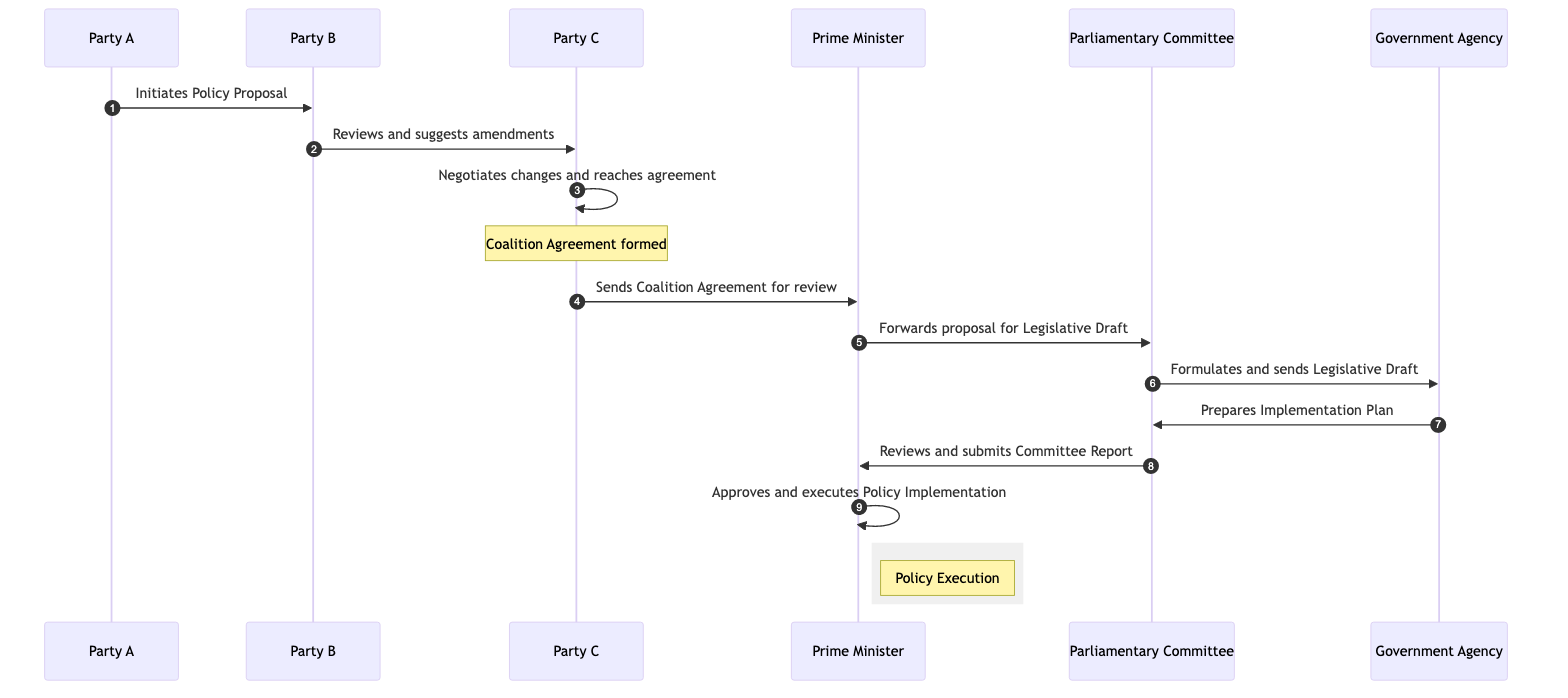What is the first action in the sequence? The first action is initiated by Party A, where they propose a Policy Proposal to Party B. This is the starting point of the diagram, signifying the initiation of the policy development process.
Answer: Party A initiates a Policy Proposal How many parties are involved in the diagram? The diagram includes three parties: Party A, Party B, and Party C. They are all mentioned as actors in the sequence, contributing to the policy development process.
Answer: Three Who reviews the Coalition Agreement after Party C? After Party C sends the Coalition Agreement, it is reviewed by the Prime Minister. This action is represented clearly in the diagram as the Prime Minister’s involvement in the agreement process.
Answer: Prime Minister Which participant sends the Legislative Draft to the Government Agency? The Parliamentary Committee sends the Legislative Draft to the Government Agency. This action indicates the flow of the Legislative Draft in the process as outlined in the sequence diagram.
Answer: Parliamentary Committee What does the Government Agency prepare? The Government Agency prepares an Implementation Plan. This step signifies the transition from legislative action to the operational aspects of policy execution.
Answer: Implementation Plan How many actions involve the Prime Minister directly? There are three actions involving the Prime Minister directly: reviewing the Coalition Agreement, forwarding the proposal for Legislative Draft, and approving/executing the Policy Implementation. Each of these actions indicates the Prime Minister's critical role in the policy development process.
Answer: Three What occurs after the Parliamentary Committee formulates the Legislative Draft? After the Parliamentary Committee formulates the Legislative Draft, it sends this draft to the Government Agency for further preparation of the Implementation Plan. This illustrates the progression from legislation to implementation.
Answer: Sends Legislative Draft to Government Agency Which action indicates the completion of policy execution? The action that indicates the completion of policy execution is when the Prime Minister approves and executes the Policy Implementation. This marks the end of the sequence for this particular policy development process.
Answer: Approves and executes the Policy Implementation 